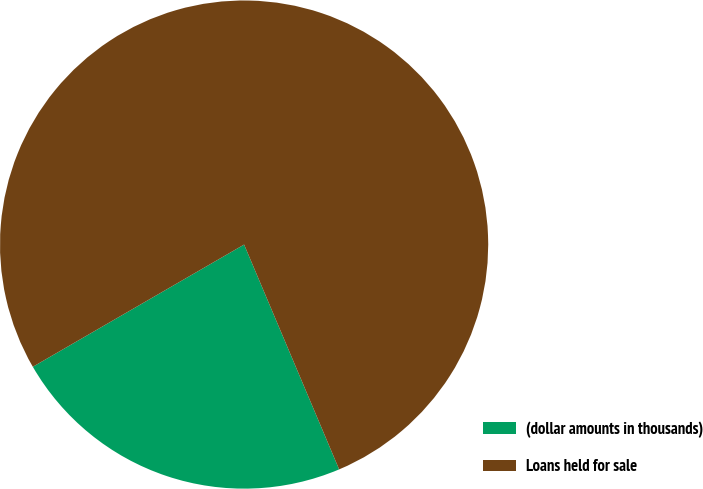Convert chart to OTSL. <chart><loc_0><loc_0><loc_500><loc_500><pie_chart><fcel>(dollar amounts in thousands)<fcel>Loans held for sale<nl><fcel>23.02%<fcel>76.98%<nl></chart> 